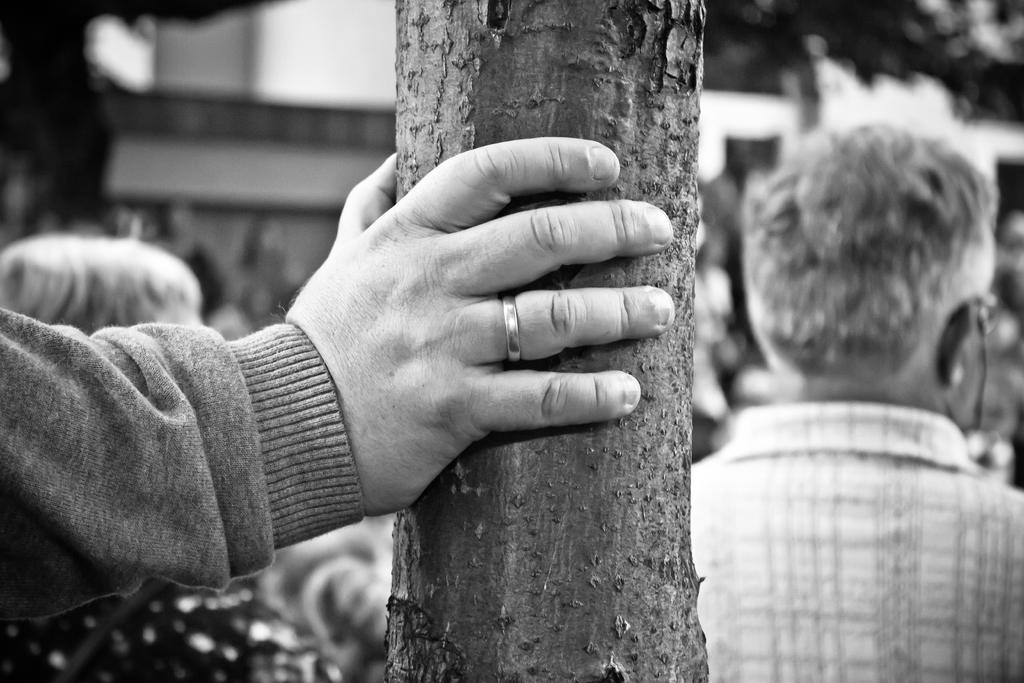What is the main subject in the center of the image? There is a tree stem in the center of the image. What can be seen on the left side of the image? There is a person's hand on the left side of the image. Can you describe the background of the image? There are people in the background of the image. Reasoning: Let's think step by step by step in order to produce the conversation. We start by identifying the main subject in the image, which is the tree stem. Then, we expand the conversation to include other elements that are also visible, such as the person's hand and the people in the background. Each question is designed to elicit a specific detail about the image that is known from the provided facts. Absurd Question/Answer: How many zippers can be seen on the tree stem in the image? There are no zippers present on the tree stem in the image. What type of rings are visible on the person's hand in the image? There are no rings visible on the person's hand in the image. What type of hearing aid is visible on the person's hand in the image? There are no hearing aids visible on the person's hand in the image. 